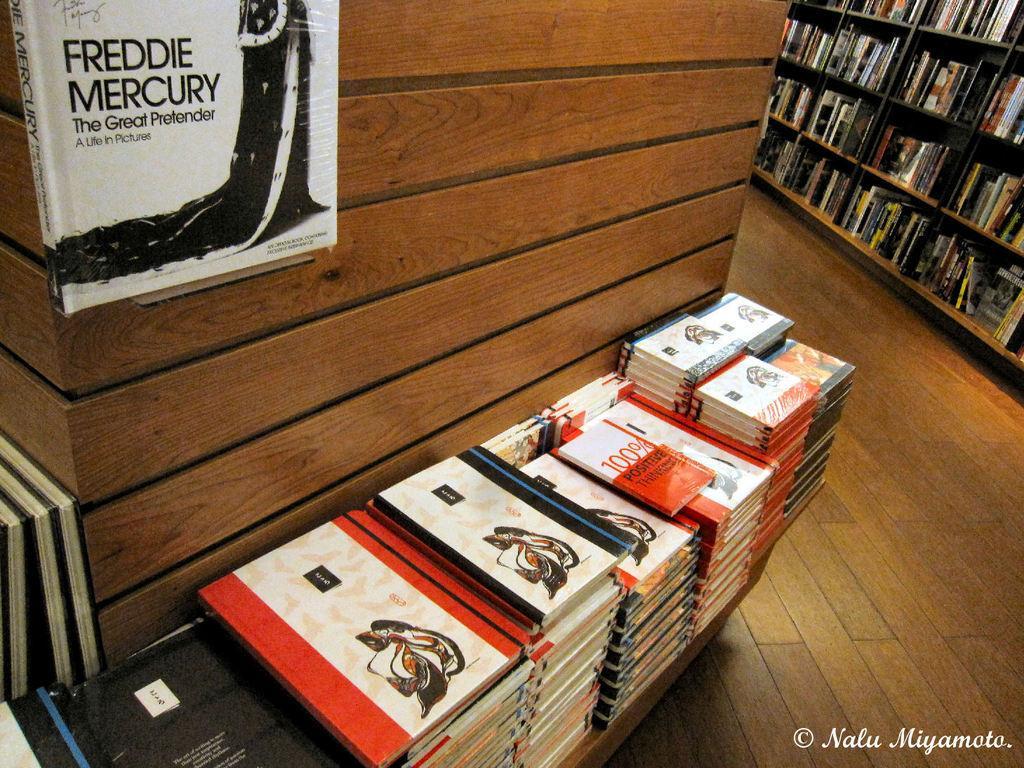Could you give a brief overview of what you see in this image? In the foreground of this image, there are books near a wooden pillar and at the top, there is another book. In the background, there is floor and the books in the rack. 